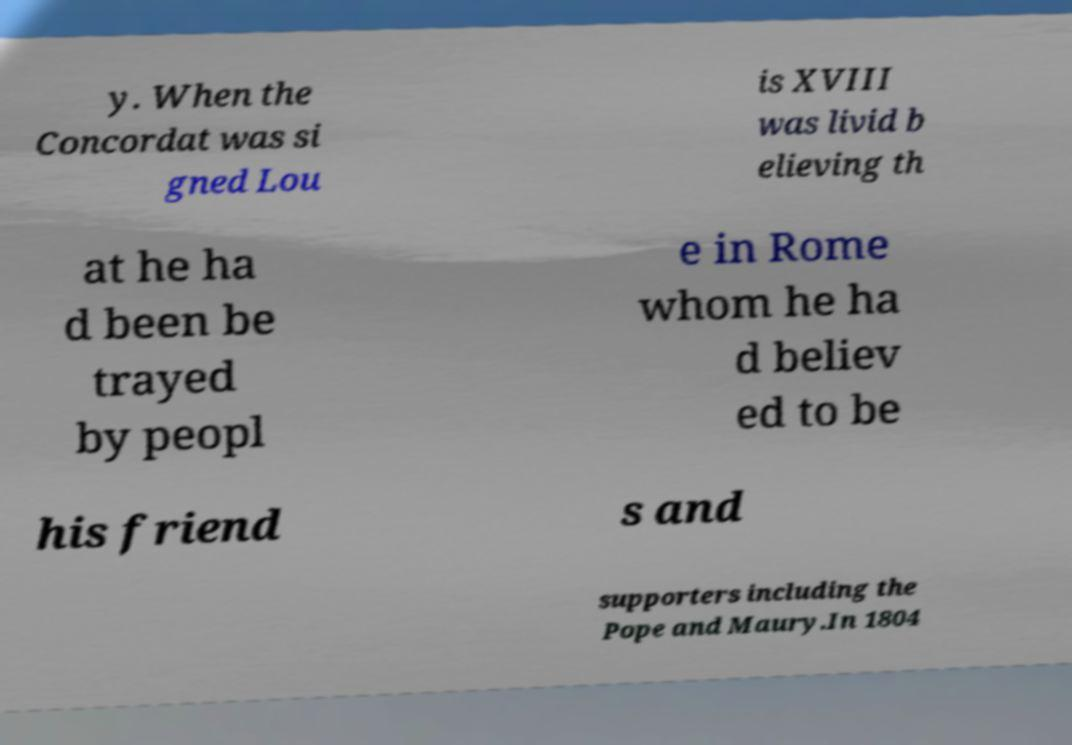What messages or text are displayed in this image? I need them in a readable, typed format. y. When the Concordat was si gned Lou is XVIII was livid b elieving th at he ha d been be trayed by peopl e in Rome whom he ha d believ ed to be his friend s and supporters including the Pope and Maury.In 1804 